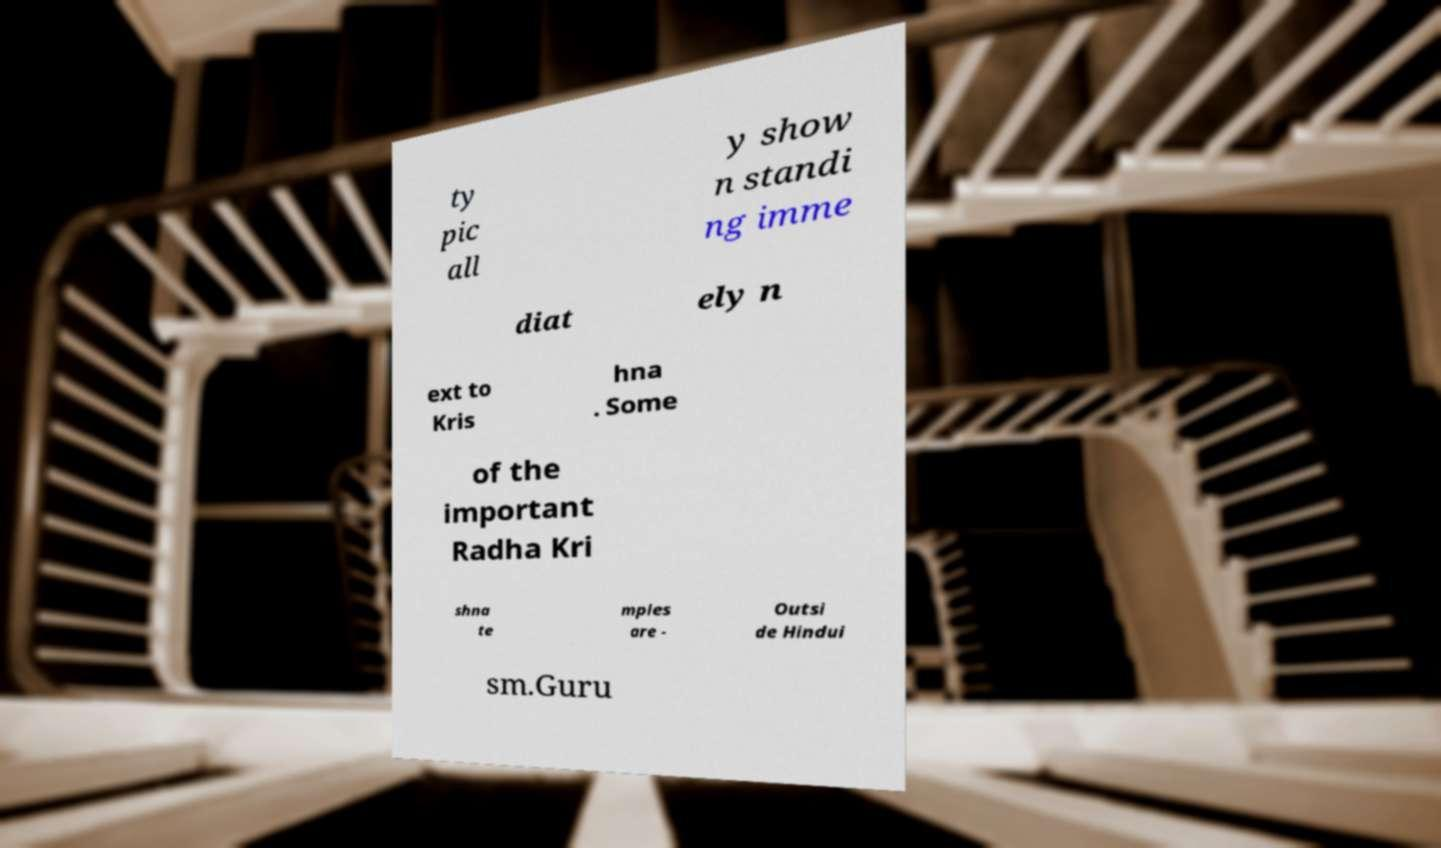Can you read and provide the text displayed in the image?This photo seems to have some interesting text. Can you extract and type it out for me? ty pic all y show n standi ng imme diat ely n ext to Kris hna . Some of the important Radha Kri shna te mples are - Outsi de Hindui sm.Guru 